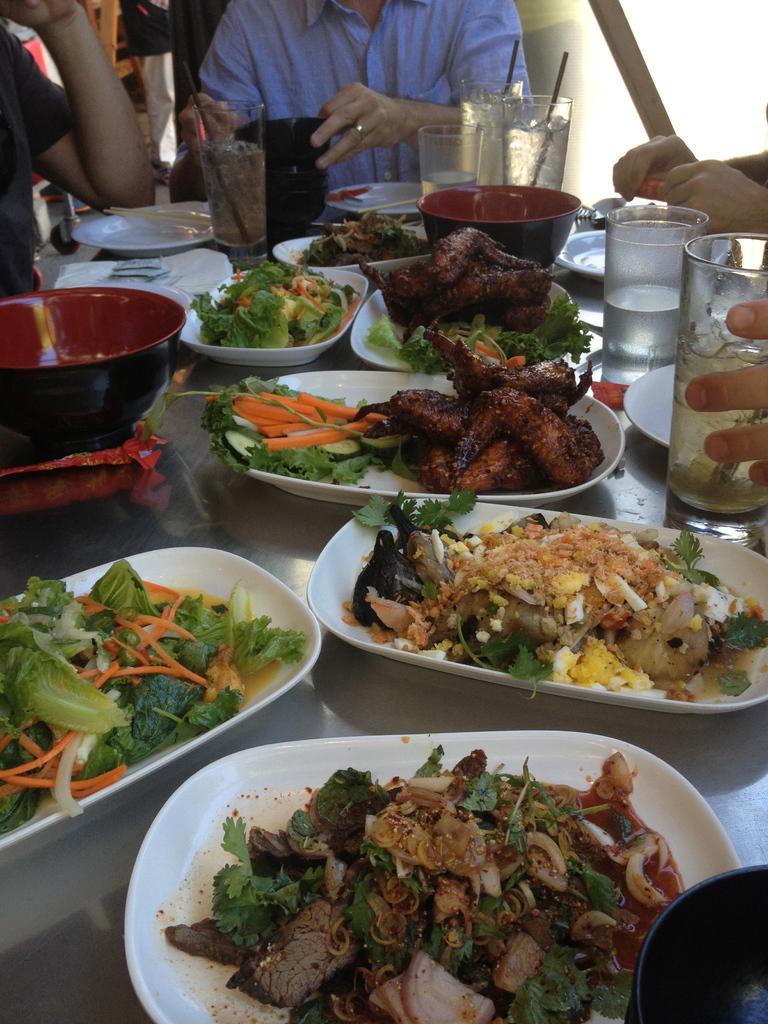How would you summarize this image in a sentence or two? In this image in the center there are foods on the table which are on the plates which is white in colour and there is spoon on the table and there are glasses, there are bowls and there are persons 